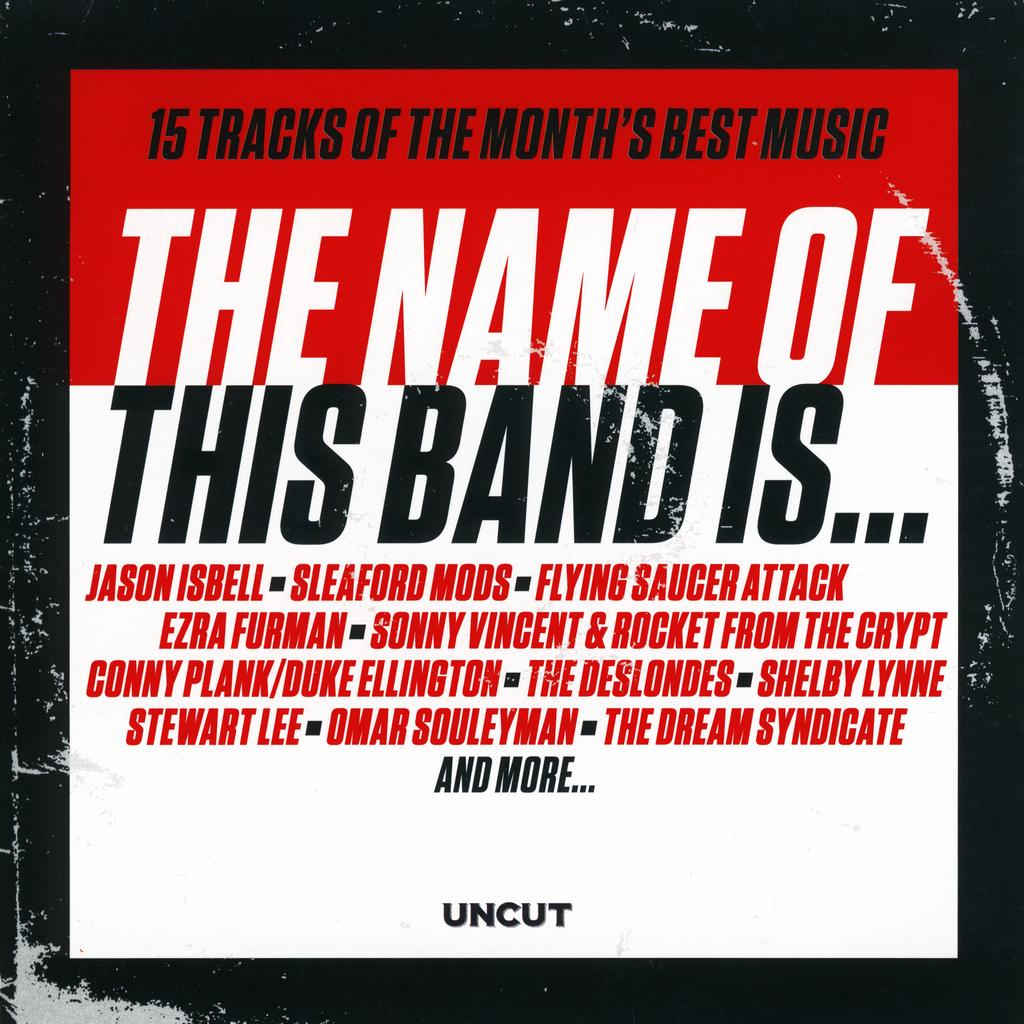<image>
Describe the image concisely. AN ALBUM COVER INTITLED THE NAME OF THIS BAND IS ... 